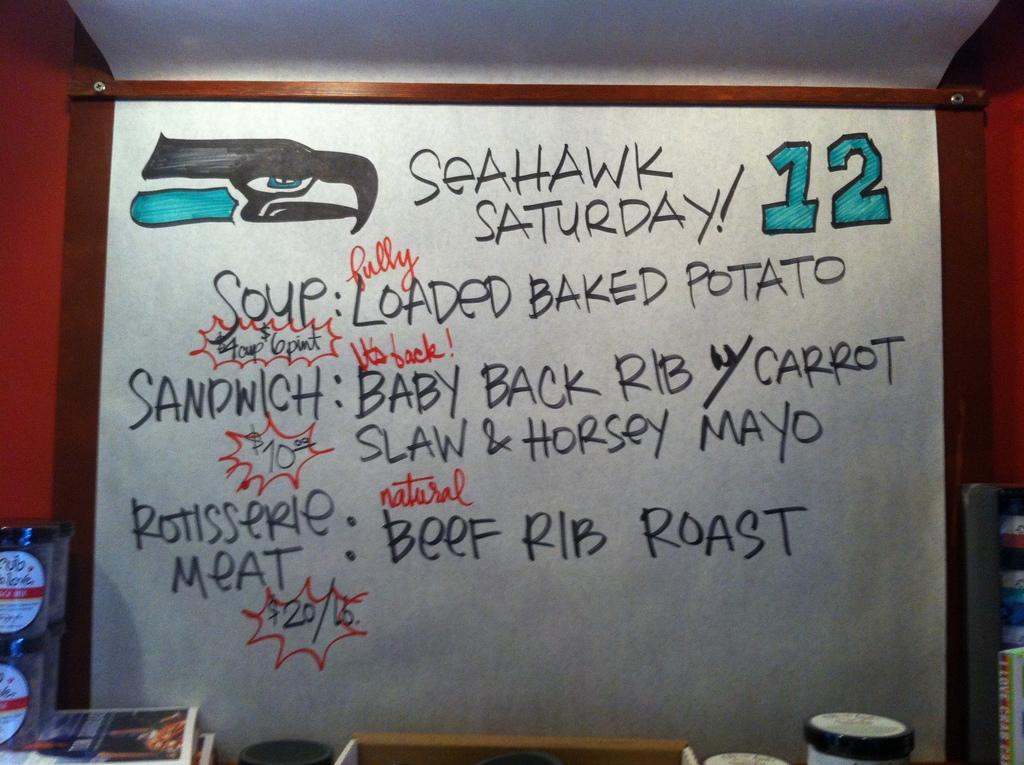<image>
Create a compact narrative representing the image presented. A restaurant advertises for Seahawk Saturday with loaded baked potato soup on special. 